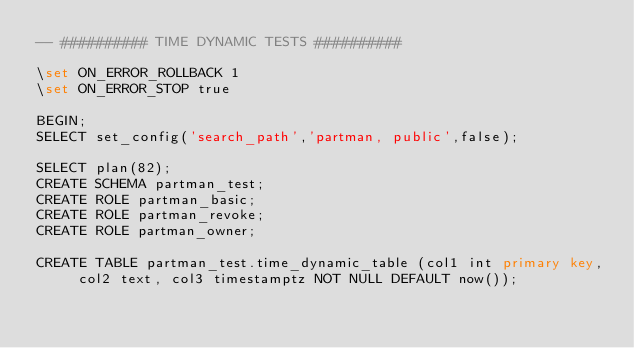Convert code to text. <code><loc_0><loc_0><loc_500><loc_500><_SQL_>-- ########## TIME DYNAMIC TESTS ##########

\set ON_ERROR_ROLLBACK 1
\set ON_ERROR_STOP true

BEGIN;
SELECT set_config('search_path','partman, public',false);

SELECT plan(82);
CREATE SCHEMA partman_test;
CREATE ROLE partman_basic;
CREATE ROLE partman_revoke;
CREATE ROLE partman_owner;

CREATE TABLE partman_test.time_dynamic_table (col1 int primary key, col2 text, col3 timestamptz NOT NULL DEFAULT now());</code> 